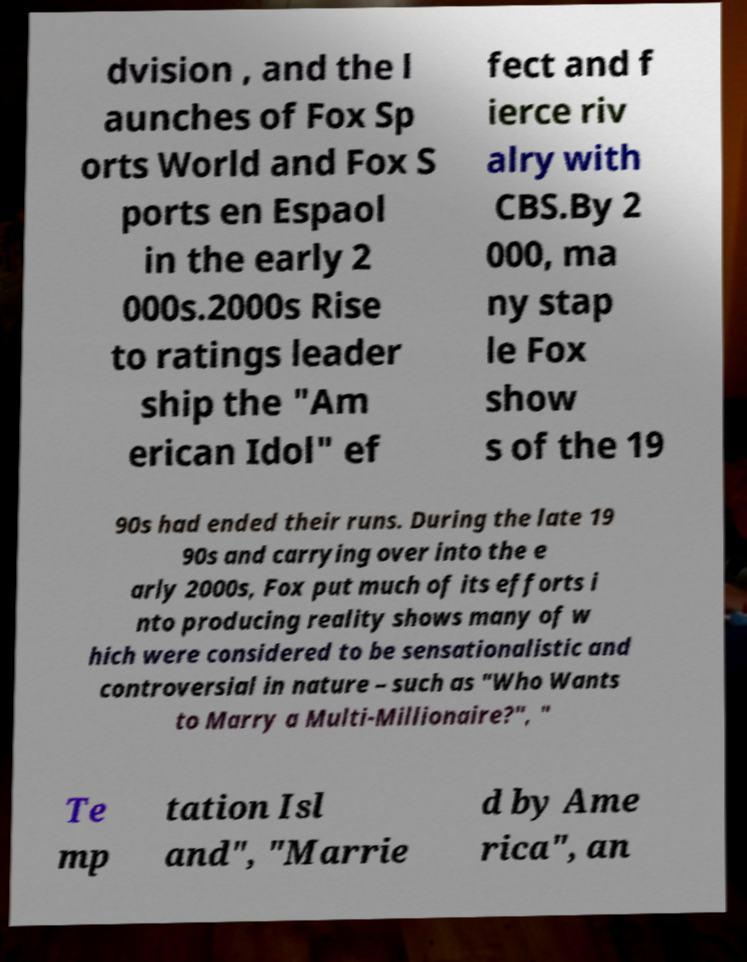I need the written content from this picture converted into text. Can you do that? dvision , and the l aunches of Fox Sp orts World and Fox S ports en Espaol in the early 2 000s.2000s Rise to ratings leader ship the "Am erican Idol" ef fect and f ierce riv alry with CBS.By 2 000, ma ny stap le Fox show s of the 19 90s had ended their runs. During the late 19 90s and carrying over into the e arly 2000s, Fox put much of its efforts i nto producing reality shows many of w hich were considered to be sensationalistic and controversial in nature – such as "Who Wants to Marry a Multi-Millionaire?", " Te mp tation Isl and", "Marrie d by Ame rica", an 